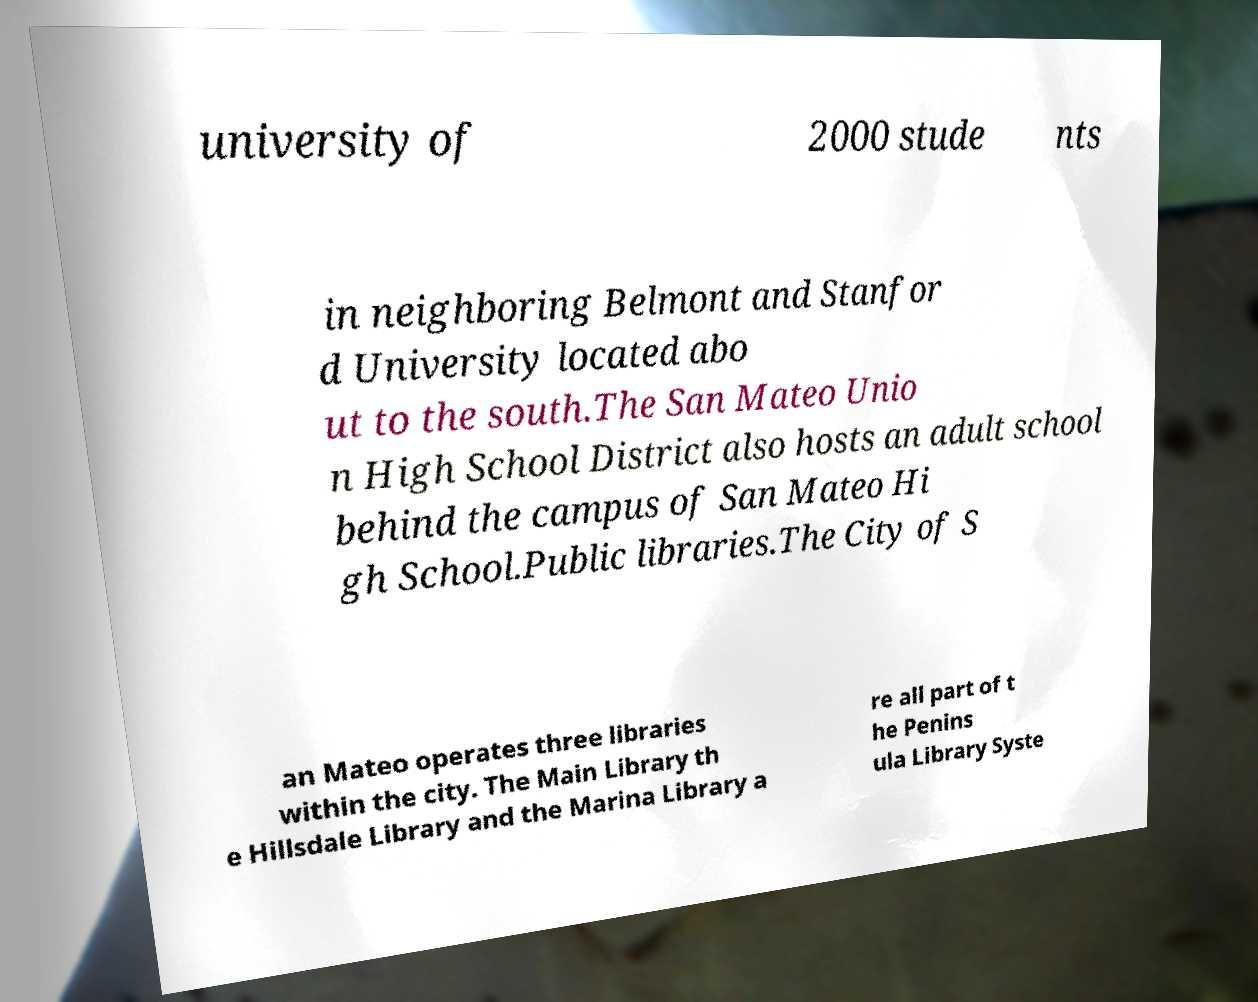For documentation purposes, I need the text within this image transcribed. Could you provide that? university of 2000 stude nts in neighboring Belmont and Stanfor d University located abo ut to the south.The San Mateo Unio n High School District also hosts an adult school behind the campus of San Mateo Hi gh School.Public libraries.The City of S an Mateo operates three libraries within the city. The Main Library th e Hillsdale Library and the Marina Library a re all part of t he Penins ula Library Syste 